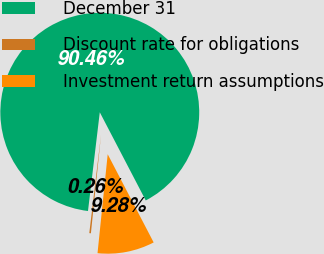<chart> <loc_0><loc_0><loc_500><loc_500><pie_chart><fcel>December 31<fcel>Discount rate for obligations<fcel>Investment return assumptions<nl><fcel>90.46%<fcel>0.26%<fcel>9.28%<nl></chart> 